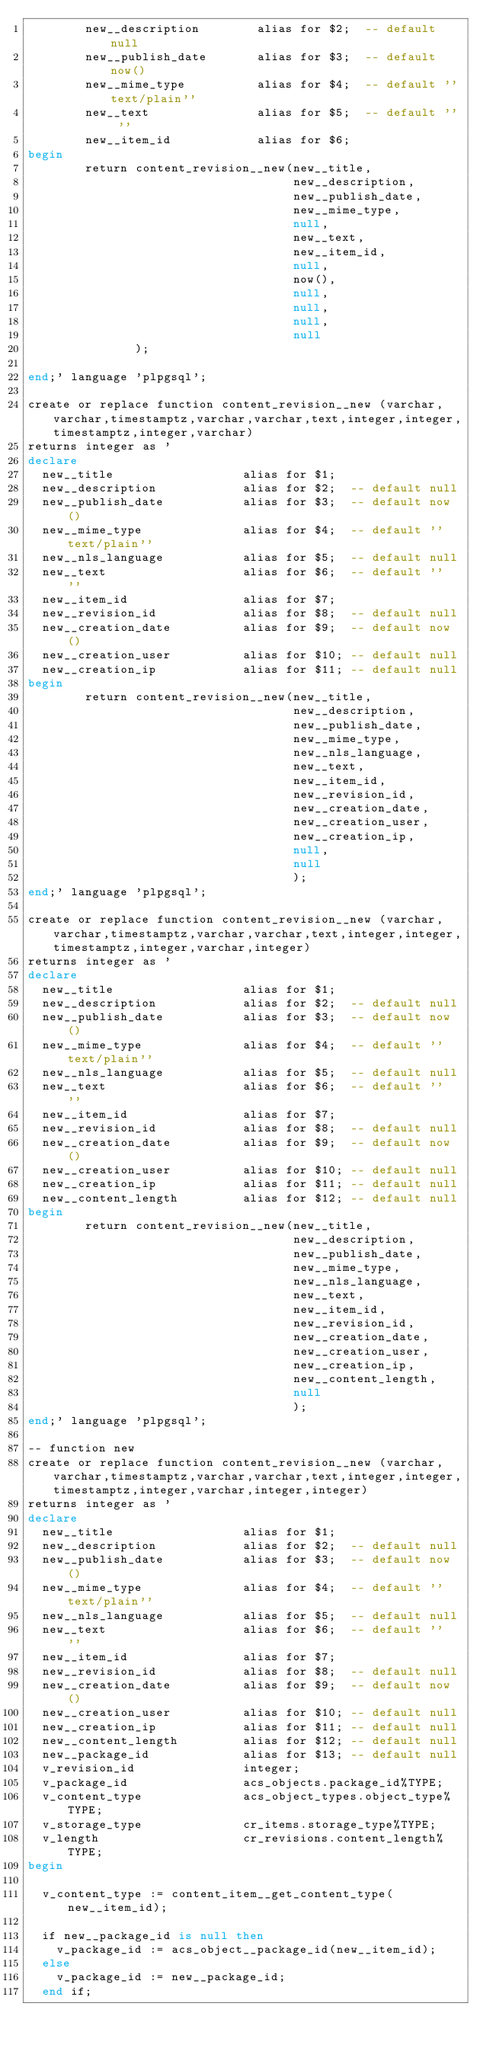Convert code to text. <code><loc_0><loc_0><loc_500><loc_500><_SQL_>        new__description        alias for $2;  -- default null
        new__publish_date       alias for $3;  -- default now()
        new__mime_type          alias for $4;  -- default ''text/plain''
        new__text               alias for $5;  -- default '' ''
        new__item_id            alias for $6;
begin
        return content_revision__new(new__title,
                                     new__description,
                                     new__publish_date,
                                     new__mime_type,
                                     null,
                                     new__text,
                                     new__item_id,
                                     null,
                                     now(),
                                     null,
                                     null,
                                     null,
                                     null
               );

end;' language 'plpgsql';

create or replace function content_revision__new (varchar,varchar,timestamptz,varchar,varchar,text,integer,integer,timestamptz,integer,varchar)
returns integer as '
declare
  new__title                  alias for $1;  
  new__description            alias for $2;  -- default null  
  new__publish_date           alias for $3;  -- default now()
  new__mime_type              alias for $4;  -- default ''text/plain''
  new__nls_language           alias for $5;  -- default null
  new__text                   alias for $6;  -- default '' ''
  new__item_id                alias for $7;  
  new__revision_id            alias for $8;  -- default null
  new__creation_date          alias for $9;  -- default now()
  new__creation_user          alias for $10; -- default null
  new__creation_ip            alias for $11; -- default null
begin
        return content_revision__new(new__title,
                                     new__description,
                                     new__publish_date,
                                     new__mime_type,
                                     new__nls_language,
                                     new__text,
                                     new__item_id,
                                     new__revision_id,
                                     new__creation_date,
                                     new__creation_user,
                                     new__creation_ip,
                                     null,
                                     null
                                     );
end;' language 'plpgsql';

create or replace function content_revision__new (varchar,varchar,timestamptz,varchar,varchar,text,integer,integer,timestamptz,integer,varchar,integer)
returns integer as '
declare
  new__title                  alias for $1;  
  new__description            alias for $2;  -- default null  
  new__publish_date           alias for $3;  -- default now()
  new__mime_type              alias for $4;  -- default ''text/plain''
  new__nls_language           alias for $5;  -- default null
  new__text                   alias for $6;  -- default '' ''
  new__item_id                alias for $7;  
  new__revision_id            alias for $8;  -- default null
  new__creation_date          alias for $9;  -- default now()
  new__creation_user          alias for $10; -- default null
  new__creation_ip            alias for $11; -- default null
  new__content_length         alias for $12; -- default null
begin
        return content_revision__new(new__title,
                                     new__description,
                                     new__publish_date,
                                     new__mime_type,
                                     new__nls_language,
                                     new__text,
                                     new__item_id,
                                     new__revision_id,
                                     new__creation_date,
                                     new__creation_user,
                                     new__creation_ip,
                                     new__content_length,
                                     null
                                     );
end;' language 'plpgsql';

-- function new
create or replace function content_revision__new (varchar,varchar,timestamptz,varchar,varchar,text,integer,integer,timestamptz,integer,varchar,integer,integer)
returns integer as '
declare
  new__title                  alias for $1;  
  new__description            alias for $2;  -- default null  
  new__publish_date           alias for $3;  -- default now()
  new__mime_type              alias for $4;  -- default ''text/plain''
  new__nls_language           alias for $5;  -- default null
  new__text                   alias for $6;  -- default '' ''
  new__item_id                alias for $7;  
  new__revision_id            alias for $8;  -- default null
  new__creation_date          alias for $9;  -- default now()
  new__creation_user          alias for $10; -- default null
  new__creation_ip            alias for $11; -- default null
  new__content_length         alias for $12; -- default null
  new__package_id             alias for $13; -- default null  
  v_revision_id               integer;       
  v_package_id                acs_objects.package_id%TYPE;
  v_content_type              acs_object_types.object_type%TYPE;
  v_storage_type              cr_items.storage_type%TYPE;
  v_length                    cr_revisions.content_length%TYPE;
begin

  v_content_type := content_item__get_content_type(new__item_id);

  if new__package_id is null then
    v_package_id := acs_object__package_id(new__item_id);
  else
    v_package_id := new__package_id;
  end if;
</code> 